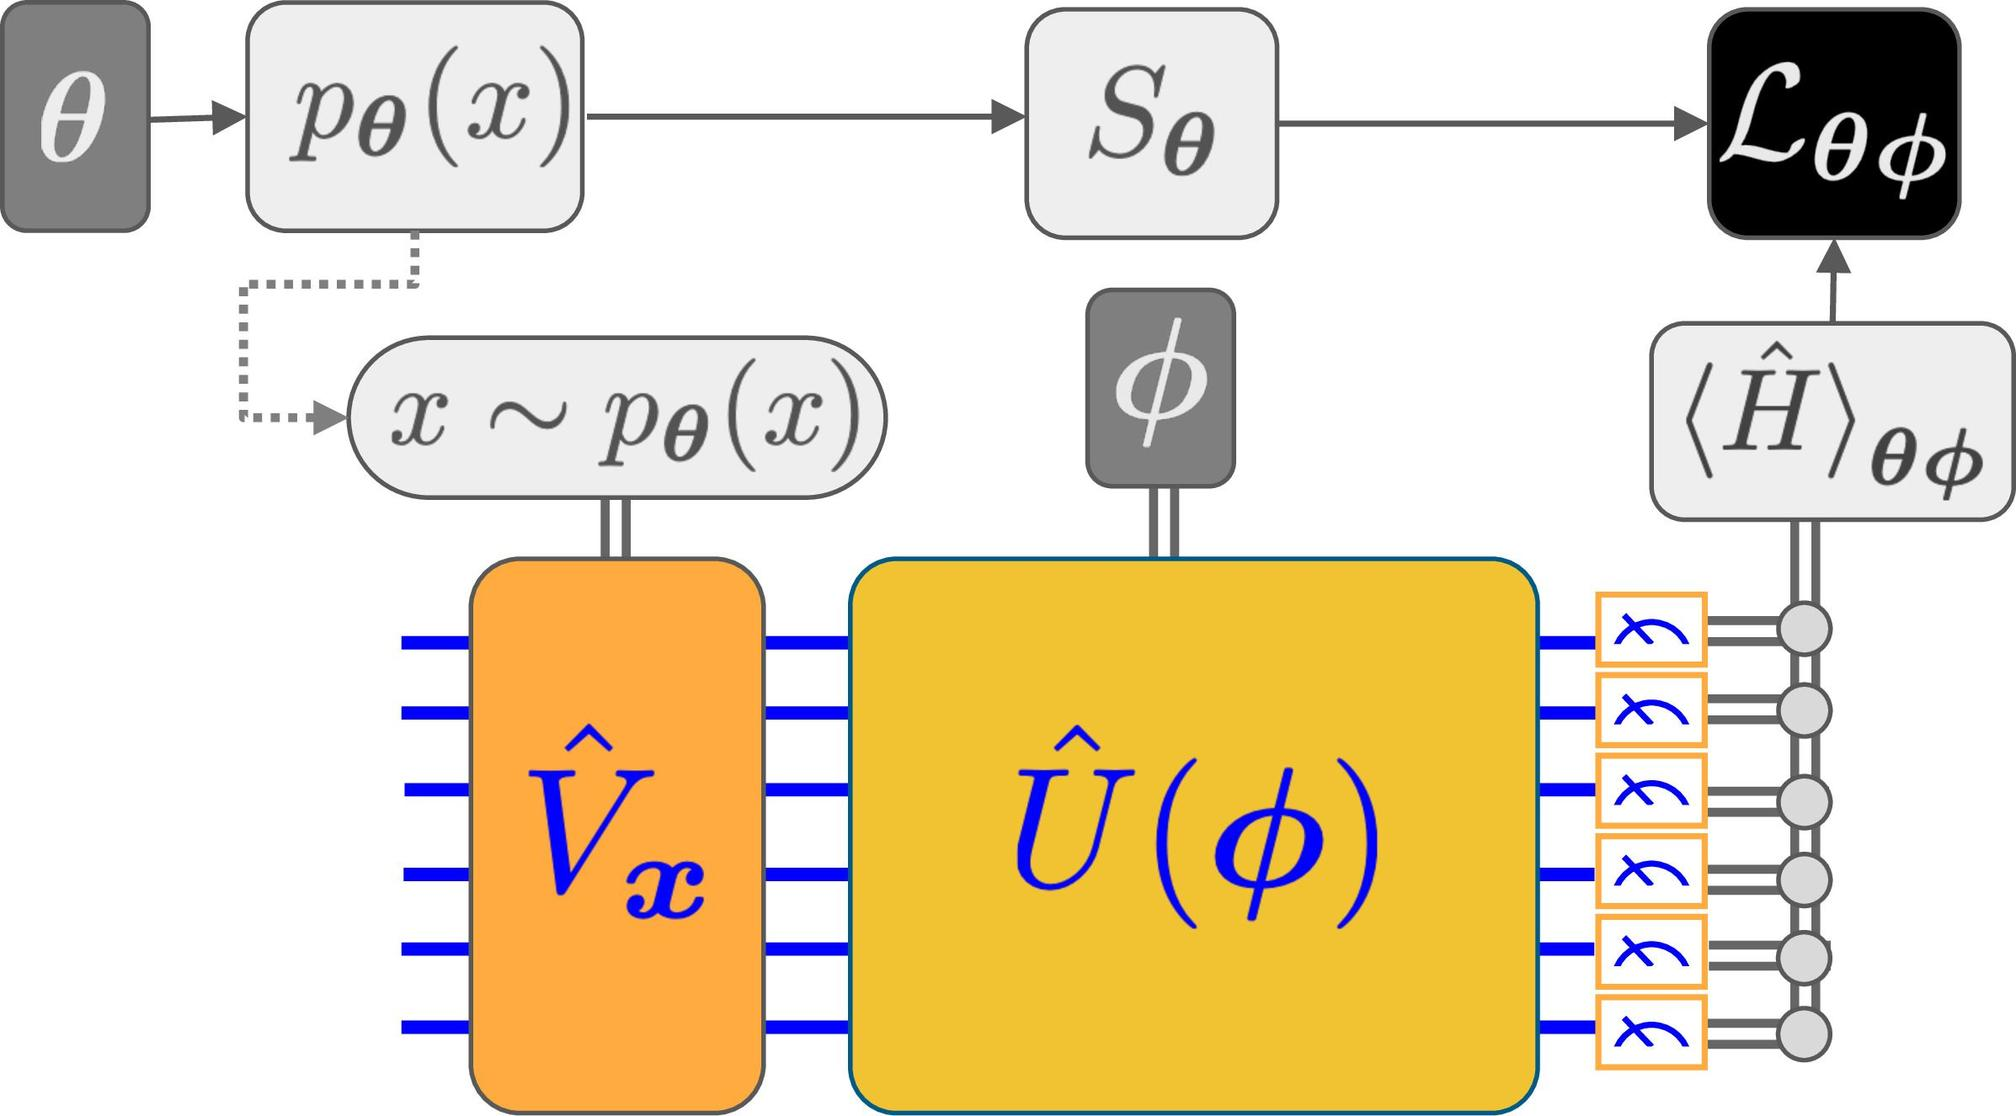Can you describe the role and possible operations performed by the modules labeled as \(\hat{V}_x\) and \(\hat{U}(\phi)\)? The module \(\hat{V}_x\) appears to function as a transformation unit, taking the state \(x\) and potentially applying a vector transformation to prepare it for further processing. The \(\hat{U}(\phi)\) module likely represents a unitary operation dependent on \(\phi\), used for evolving the state in a quantum context, ensuring that the state development is coherent and maintains quantum mechanical properties, crucial for subsequent analysis or measurement in the system. 